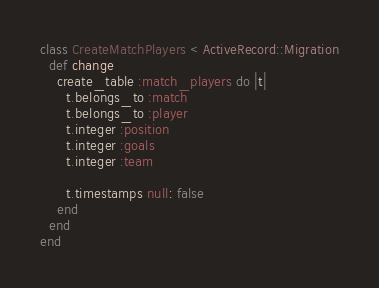<code> <loc_0><loc_0><loc_500><loc_500><_Ruby_>class CreateMatchPlayers < ActiveRecord::Migration
  def change
    create_table :match_players do |t|
      t.belongs_to :match
      t.belongs_to :player
      t.integer :position
      t.integer :goals
      t.integer :team

      t.timestamps null: false
    end
  end
end
</code> 